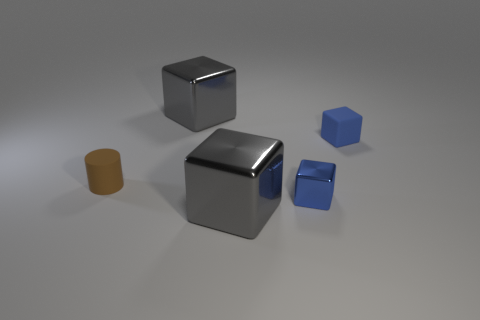How many metallic things are on the left side of the blue shiny thing and in front of the tiny brown object?
Give a very brief answer. 1. Is there any other thing that has the same color as the tiny matte cylinder?
Make the answer very short. No. How many metallic things are brown things or gray cubes?
Keep it short and to the point. 2. The gray object in front of the gray object behind the big gray metallic thing that is in front of the tiny cylinder is made of what material?
Keep it short and to the point. Metal. The large cube that is to the left of the big thing that is in front of the small blue metallic object is made of what material?
Offer a very short reply. Metal. There is a matte cube that is on the right side of the small cylinder; is it the same size as the gray shiny thing behind the tiny blue matte thing?
Your answer should be compact. No. Is there any other thing that is the same material as the cylinder?
Offer a very short reply. Yes. What number of tiny objects are brown cylinders or blue blocks?
Provide a succinct answer. 3. How many things are either large cubes in front of the rubber cylinder or big cyan shiny balls?
Your answer should be very brief. 1. Is the color of the tiny rubber cylinder the same as the small matte block?
Ensure brevity in your answer.  No. 